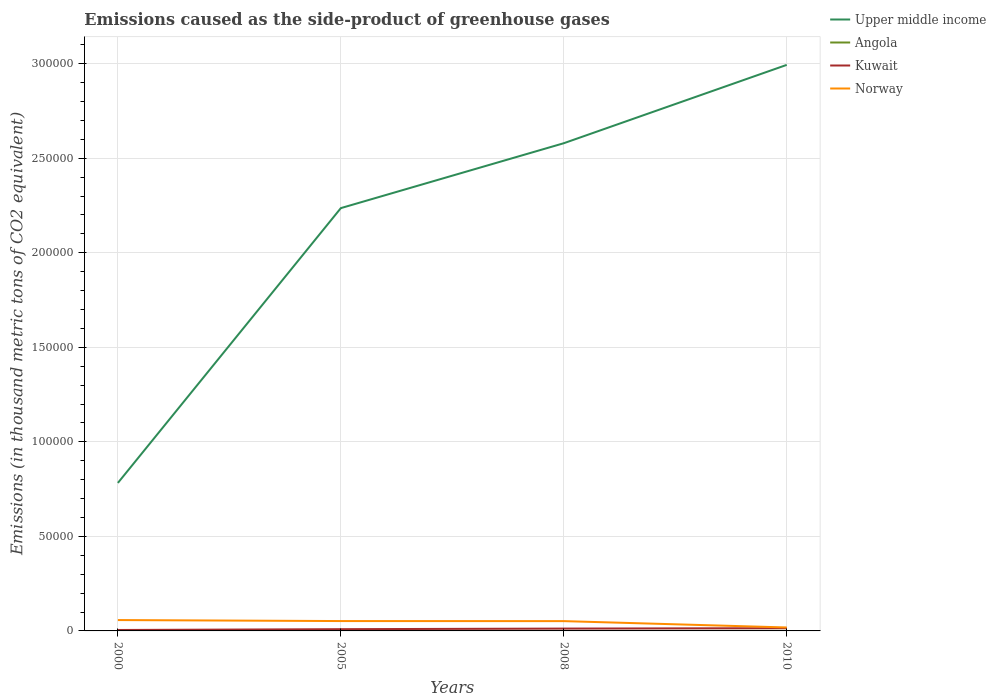How many different coloured lines are there?
Offer a terse response. 4. Does the line corresponding to Norway intersect with the line corresponding to Kuwait?
Ensure brevity in your answer.  No. Is the number of lines equal to the number of legend labels?
Your response must be concise. Yes. Across all years, what is the maximum emissions caused as the side-product of greenhouse gases in Upper middle income?
Your response must be concise. 7.83e+04. In which year was the emissions caused as the side-product of greenhouse gases in Angola maximum?
Ensure brevity in your answer.  2000. What is the total emissions caused as the side-product of greenhouse gases in Upper middle income in the graph?
Your response must be concise. -2.21e+05. What is the difference between the highest and the second highest emissions caused as the side-product of greenhouse gases in Kuwait?
Offer a terse response. 952.8. What is the difference between the highest and the lowest emissions caused as the side-product of greenhouse gases in Angola?
Provide a succinct answer. 2. How many lines are there?
Keep it short and to the point. 4. Where does the legend appear in the graph?
Provide a short and direct response. Top right. How many legend labels are there?
Your answer should be compact. 4. How are the legend labels stacked?
Give a very brief answer. Vertical. What is the title of the graph?
Give a very brief answer. Emissions caused as the side-product of greenhouse gases. Does "South Sudan" appear as one of the legend labels in the graph?
Your response must be concise. No. What is the label or title of the X-axis?
Keep it short and to the point. Years. What is the label or title of the Y-axis?
Ensure brevity in your answer.  Emissions (in thousand metric tons of CO2 equivalent). What is the Emissions (in thousand metric tons of CO2 equivalent) in Upper middle income in 2000?
Your answer should be very brief. 7.83e+04. What is the Emissions (in thousand metric tons of CO2 equivalent) of Angola in 2000?
Offer a very short reply. 0.7. What is the Emissions (in thousand metric tons of CO2 equivalent) in Kuwait in 2000?
Offer a terse response. 498.2. What is the Emissions (in thousand metric tons of CO2 equivalent) in Norway in 2000?
Your response must be concise. 5742.8. What is the Emissions (in thousand metric tons of CO2 equivalent) in Upper middle income in 2005?
Give a very brief answer. 2.24e+05. What is the Emissions (in thousand metric tons of CO2 equivalent) of Angola in 2005?
Provide a short and direct response. 19.3. What is the Emissions (in thousand metric tons of CO2 equivalent) in Kuwait in 2005?
Keep it short and to the point. 925.6. What is the Emissions (in thousand metric tons of CO2 equivalent) in Norway in 2005?
Ensure brevity in your answer.  5218.5. What is the Emissions (in thousand metric tons of CO2 equivalent) in Upper middle income in 2008?
Ensure brevity in your answer.  2.58e+05. What is the Emissions (in thousand metric tons of CO2 equivalent) in Angola in 2008?
Give a very brief answer. 26.5. What is the Emissions (in thousand metric tons of CO2 equivalent) of Kuwait in 2008?
Keep it short and to the point. 1235.4. What is the Emissions (in thousand metric tons of CO2 equivalent) in Norway in 2008?
Your response must be concise. 5179.9. What is the Emissions (in thousand metric tons of CO2 equivalent) in Upper middle income in 2010?
Your response must be concise. 2.99e+05. What is the Emissions (in thousand metric tons of CO2 equivalent) in Kuwait in 2010?
Give a very brief answer. 1451. What is the Emissions (in thousand metric tons of CO2 equivalent) of Norway in 2010?
Your response must be concise. 1823. Across all years, what is the maximum Emissions (in thousand metric tons of CO2 equivalent) in Upper middle income?
Keep it short and to the point. 2.99e+05. Across all years, what is the maximum Emissions (in thousand metric tons of CO2 equivalent) of Kuwait?
Your response must be concise. 1451. Across all years, what is the maximum Emissions (in thousand metric tons of CO2 equivalent) of Norway?
Keep it short and to the point. 5742.8. Across all years, what is the minimum Emissions (in thousand metric tons of CO2 equivalent) in Upper middle income?
Give a very brief answer. 7.83e+04. Across all years, what is the minimum Emissions (in thousand metric tons of CO2 equivalent) of Angola?
Offer a terse response. 0.7. Across all years, what is the minimum Emissions (in thousand metric tons of CO2 equivalent) of Kuwait?
Give a very brief answer. 498.2. Across all years, what is the minimum Emissions (in thousand metric tons of CO2 equivalent) of Norway?
Your answer should be compact. 1823. What is the total Emissions (in thousand metric tons of CO2 equivalent) of Upper middle income in the graph?
Your response must be concise. 8.59e+05. What is the total Emissions (in thousand metric tons of CO2 equivalent) in Angola in the graph?
Provide a short and direct response. 77.5. What is the total Emissions (in thousand metric tons of CO2 equivalent) of Kuwait in the graph?
Your answer should be compact. 4110.2. What is the total Emissions (in thousand metric tons of CO2 equivalent) of Norway in the graph?
Your answer should be very brief. 1.80e+04. What is the difference between the Emissions (in thousand metric tons of CO2 equivalent) of Upper middle income in 2000 and that in 2005?
Give a very brief answer. -1.45e+05. What is the difference between the Emissions (in thousand metric tons of CO2 equivalent) of Angola in 2000 and that in 2005?
Provide a short and direct response. -18.6. What is the difference between the Emissions (in thousand metric tons of CO2 equivalent) of Kuwait in 2000 and that in 2005?
Keep it short and to the point. -427.4. What is the difference between the Emissions (in thousand metric tons of CO2 equivalent) in Norway in 2000 and that in 2005?
Give a very brief answer. 524.3. What is the difference between the Emissions (in thousand metric tons of CO2 equivalent) of Upper middle income in 2000 and that in 2008?
Ensure brevity in your answer.  -1.80e+05. What is the difference between the Emissions (in thousand metric tons of CO2 equivalent) in Angola in 2000 and that in 2008?
Your answer should be compact. -25.8. What is the difference between the Emissions (in thousand metric tons of CO2 equivalent) of Kuwait in 2000 and that in 2008?
Provide a short and direct response. -737.2. What is the difference between the Emissions (in thousand metric tons of CO2 equivalent) in Norway in 2000 and that in 2008?
Ensure brevity in your answer.  562.9. What is the difference between the Emissions (in thousand metric tons of CO2 equivalent) in Upper middle income in 2000 and that in 2010?
Provide a succinct answer. -2.21e+05. What is the difference between the Emissions (in thousand metric tons of CO2 equivalent) in Angola in 2000 and that in 2010?
Provide a succinct answer. -30.3. What is the difference between the Emissions (in thousand metric tons of CO2 equivalent) of Kuwait in 2000 and that in 2010?
Provide a short and direct response. -952.8. What is the difference between the Emissions (in thousand metric tons of CO2 equivalent) in Norway in 2000 and that in 2010?
Provide a succinct answer. 3919.8. What is the difference between the Emissions (in thousand metric tons of CO2 equivalent) in Upper middle income in 2005 and that in 2008?
Keep it short and to the point. -3.43e+04. What is the difference between the Emissions (in thousand metric tons of CO2 equivalent) in Angola in 2005 and that in 2008?
Offer a terse response. -7.2. What is the difference between the Emissions (in thousand metric tons of CO2 equivalent) of Kuwait in 2005 and that in 2008?
Make the answer very short. -309.8. What is the difference between the Emissions (in thousand metric tons of CO2 equivalent) in Norway in 2005 and that in 2008?
Provide a succinct answer. 38.6. What is the difference between the Emissions (in thousand metric tons of CO2 equivalent) of Upper middle income in 2005 and that in 2010?
Provide a succinct answer. -7.58e+04. What is the difference between the Emissions (in thousand metric tons of CO2 equivalent) in Kuwait in 2005 and that in 2010?
Ensure brevity in your answer.  -525.4. What is the difference between the Emissions (in thousand metric tons of CO2 equivalent) in Norway in 2005 and that in 2010?
Provide a succinct answer. 3395.5. What is the difference between the Emissions (in thousand metric tons of CO2 equivalent) of Upper middle income in 2008 and that in 2010?
Give a very brief answer. -4.14e+04. What is the difference between the Emissions (in thousand metric tons of CO2 equivalent) in Angola in 2008 and that in 2010?
Give a very brief answer. -4.5. What is the difference between the Emissions (in thousand metric tons of CO2 equivalent) of Kuwait in 2008 and that in 2010?
Your answer should be compact. -215.6. What is the difference between the Emissions (in thousand metric tons of CO2 equivalent) in Norway in 2008 and that in 2010?
Your response must be concise. 3356.9. What is the difference between the Emissions (in thousand metric tons of CO2 equivalent) in Upper middle income in 2000 and the Emissions (in thousand metric tons of CO2 equivalent) in Angola in 2005?
Offer a very short reply. 7.83e+04. What is the difference between the Emissions (in thousand metric tons of CO2 equivalent) of Upper middle income in 2000 and the Emissions (in thousand metric tons of CO2 equivalent) of Kuwait in 2005?
Offer a terse response. 7.74e+04. What is the difference between the Emissions (in thousand metric tons of CO2 equivalent) of Upper middle income in 2000 and the Emissions (in thousand metric tons of CO2 equivalent) of Norway in 2005?
Offer a terse response. 7.31e+04. What is the difference between the Emissions (in thousand metric tons of CO2 equivalent) of Angola in 2000 and the Emissions (in thousand metric tons of CO2 equivalent) of Kuwait in 2005?
Your answer should be very brief. -924.9. What is the difference between the Emissions (in thousand metric tons of CO2 equivalent) in Angola in 2000 and the Emissions (in thousand metric tons of CO2 equivalent) in Norway in 2005?
Your answer should be very brief. -5217.8. What is the difference between the Emissions (in thousand metric tons of CO2 equivalent) of Kuwait in 2000 and the Emissions (in thousand metric tons of CO2 equivalent) of Norway in 2005?
Give a very brief answer. -4720.3. What is the difference between the Emissions (in thousand metric tons of CO2 equivalent) of Upper middle income in 2000 and the Emissions (in thousand metric tons of CO2 equivalent) of Angola in 2008?
Your response must be concise. 7.83e+04. What is the difference between the Emissions (in thousand metric tons of CO2 equivalent) in Upper middle income in 2000 and the Emissions (in thousand metric tons of CO2 equivalent) in Kuwait in 2008?
Your answer should be very brief. 7.70e+04. What is the difference between the Emissions (in thousand metric tons of CO2 equivalent) of Upper middle income in 2000 and the Emissions (in thousand metric tons of CO2 equivalent) of Norway in 2008?
Your answer should be compact. 7.31e+04. What is the difference between the Emissions (in thousand metric tons of CO2 equivalent) of Angola in 2000 and the Emissions (in thousand metric tons of CO2 equivalent) of Kuwait in 2008?
Provide a succinct answer. -1234.7. What is the difference between the Emissions (in thousand metric tons of CO2 equivalent) of Angola in 2000 and the Emissions (in thousand metric tons of CO2 equivalent) of Norway in 2008?
Keep it short and to the point. -5179.2. What is the difference between the Emissions (in thousand metric tons of CO2 equivalent) in Kuwait in 2000 and the Emissions (in thousand metric tons of CO2 equivalent) in Norway in 2008?
Provide a succinct answer. -4681.7. What is the difference between the Emissions (in thousand metric tons of CO2 equivalent) in Upper middle income in 2000 and the Emissions (in thousand metric tons of CO2 equivalent) in Angola in 2010?
Offer a very short reply. 7.83e+04. What is the difference between the Emissions (in thousand metric tons of CO2 equivalent) in Upper middle income in 2000 and the Emissions (in thousand metric tons of CO2 equivalent) in Kuwait in 2010?
Ensure brevity in your answer.  7.68e+04. What is the difference between the Emissions (in thousand metric tons of CO2 equivalent) in Upper middle income in 2000 and the Emissions (in thousand metric tons of CO2 equivalent) in Norway in 2010?
Make the answer very short. 7.65e+04. What is the difference between the Emissions (in thousand metric tons of CO2 equivalent) of Angola in 2000 and the Emissions (in thousand metric tons of CO2 equivalent) of Kuwait in 2010?
Make the answer very short. -1450.3. What is the difference between the Emissions (in thousand metric tons of CO2 equivalent) in Angola in 2000 and the Emissions (in thousand metric tons of CO2 equivalent) in Norway in 2010?
Make the answer very short. -1822.3. What is the difference between the Emissions (in thousand metric tons of CO2 equivalent) of Kuwait in 2000 and the Emissions (in thousand metric tons of CO2 equivalent) of Norway in 2010?
Ensure brevity in your answer.  -1324.8. What is the difference between the Emissions (in thousand metric tons of CO2 equivalent) of Upper middle income in 2005 and the Emissions (in thousand metric tons of CO2 equivalent) of Angola in 2008?
Your answer should be very brief. 2.24e+05. What is the difference between the Emissions (in thousand metric tons of CO2 equivalent) in Upper middle income in 2005 and the Emissions (in thousand metric tons of CO2 equivalent) in Kuwait in 2008?
Offer a very short reply. 2.22e+05. What is the difference between the Emissions (in thousand metric tons of CO2 equivalent) of Upper middle income in 2005 and the Emissions (in thousand metric tons of CO2 equivalent) of Norway in 2008?
Your answer should be compact. 2.18e+05. What is the difference between the Emissions (in thousand metric tons of CO2 equivalent) in Angola in 2005 and the Emissions (in thousand metric tons of CO2 equivalent) in Kuwait in 2008?
Make the answer very short. -1216.1. What is the difference between the Emissions (in thousand metric tons of CO2 equivalent) in Angola in 2005 and the Emissions (in thousand metric tons of CO2 equivalent) in Norway in 2008?
Provide a succinct answer. -5160.6. What is the difference between the Emissions (in thousand metric tons of CO2 equivalent) in Kuwait in 2005 and the Emissions (in thousand metric tons of CO2 equivalent) in Norway in 2008?
Your response must be concise. -4254.3. What is the difference between the Emissions (in thousand metric tons of CO2 equivalent) in Upper middle income in 2005 and the Emissions (in thousand metric tons of CO2 equivalent) in Angola in 2010?
Ensure brevity in your answer.  2.24e+05. What is the difference between the Emissions (in thousand metric tons of CO2 equivalent) in Upper middle income in 2005 and the Emissions (in thousand metric tons of CO2 equivalent) in Kuwait in 2010?
Give a very brief answer. 2.22e+05. What is the difference between the Emissions (in thousand metric tons of CO2 equivalent) in Upper middle income in 2005 and the Emissions (in thousand metric tons of CO2 equivalent) in Norway in 2010?
Offer a terse response. 2.22e+05. What is the difference between the Emissions (in thousand metric tons of CO2 equivalent) in Angola in 2005 and the Emissions (in thousand metric tons of CO2 equivalent) in Kuwait in 2010?
Give a very brief answer. -1431.7. What is the difference between the Emissions (in thousand metric tons of CO2 equivalent) of Angola in 2005 and the Emissions (in thousand metric tons of CO2 equivalent) of Norway in 2010?
Your response must be concise. -1803.7. What is the difference between the Emissions (in thousand metric tons of CO2 equivalent) of Kuwait in 2005 and the Emissions (in thousand metric tons of CO2 equivalent) of Norway in 2010?
Your answer should be very brief. -897.4. What is the difference between the Emissions (in thousand metric tons of CO2 equivalent) of Upper middle income in 2008 and the Emissions (in thousand metric tons of CO2 equivalent) of Angola in 2010?
Your response must be concise. 2.58e+05. What is the difference between the Emissions (in thousand metric tons of CO2 equivalent) of Upper middle income in 2008 and the Emissions (in thousand metric tons of CO2 equivalent) of Kuwait in 2010?
Offer a very short reply. 2.57e+05. What is the difference between the Emissions (in thousand metric tons of CO2 equivalent) in Upper middle income in 2008 and the Emissions (in thousand metric tons of CO2 equivalent) in Norway in 2010?
Make the answer very short. 2.56e+05. What is the difference between the Emissions (in thousand metric tons of CO2 equivalent) of Angola in 2008 and the Emissions (in thousand metric tons of CO2 equivalent) of Kuwait in 2010?
Provide a succinct answer. -1424.5. What is the difference between the Emissions (in thousand metric tons of CO2 equivalent) of Angola in 2008 and the Emissions (in thousand metric tons of CO2 equivalent) of Norway in 2010?
Offer a very short reply. -1796.5. What is the difference between the Emissions (in thousand metric tons of CO2 equivalent) of Kuwait in 2008 and the Emissions (in thousand metric tons of CO2 equivalent) of Norway in 2010?
Offer a very short reply. -587.6. What is the average Emissions (in thousand metric tons of CO2 equivalent) of Upper middle income per year?
Your answer should be compact. 2.15e+05. What is the average Emissions (in thousand metric tons of CO2 equivalent) of Angola per year?
Ensure brevity in your answer.  19.38. What is the average Emissions (in thousand metric tons of CO2 equivalent) in Kuwait per year?
Your response must be concise. 1027.55. What is the average Emissions (in thousand metric tons of CO2 equivalent) of Norway per year?
Ensure brevity in your answer.  4491.05. In the year 2000, what is the difference between the Emissions (in thousand metric tons of CO2 equivalent) in Upper middle income and Emissions (in thousand metric tons of CO2 equivalent) in Angola?
Ensure brevity in your answer.  7.83e+04. In the year 2000, what is the difference between the Emissions (in thousand metric tons of CO2 equivalent) of Upper middle income and Emissions (in thousand metric tons of CO2 equivalent) of Kuwait?
Your answer should be compact. 7.78e+04. In the year 2000, what is the difference between the Emissions (in thousand metric tons of CO2 equivalent) of Upper middle income and Emissions (in thousand metric tons of CO2 equivalent) of Norway?
Provide a succinct answer. 7.25e+04. In the year 2000, what is the difference between the Emissions (in thousand metric tons of CO2 equivalent) in Angola and Emissions (in thousand metric tons of CO2 equivalent) in Kuwait?
Your response must be concise. -497.5. In the year 2000, what is the difference between the Emissions (in thousand metric tons of CO2 equivalent) of Angola and Emissions (in thousand metric tons of CO2 equivalent) of Norway?
Provide a succinct answer. -5742.1. In the year 2000, what is the difference between the Emissions (in thousand metric tons of CO2 equivalent) of Kuwait and Emissions (in thousand metric tons of CO2 equivalent) of Norway?
Your answer should be very brief. -5244.6. In the year 2005, what is the difference between the Emissions (in thousand metric tons of CO2 equivalent) in Upper middle income and Emissions (in thousand metric tons of CO2 equivalent) in Angola?
Give a very brief answer. 2.24e+05. In the year 2005, what is the difference between the Emissions (in thousand metric tons of CO2 equivalent) in Upper middle income and Emissions (in thousand metric tons of CO2 equivalent) in Kuwait?
Ensure brevity in your answer.  2.23e+05. In the year 2005, what is the difference between the Emissions (in thousand metric tons of CO2 equivalent) of Upper middle income and Emissions (in thousand metric tons of CO2 equivalent) of Norway?
Ensure brevity in your answer.  2.18e+05. In the year 2005, what is the difference between the Emissions (in thousand metric tons of CO2 equivalent) in Angola and Emissions (in thousand metric tons of CO2 equivalent) in Kuwait?
Provide a succinct answer. -906.3. In the year 2005, what is the difference between the Emissions (in thousand metric tons of CO2 equivalent) of Angola and Emissions (in thousand metric tons of CO2 equivalent) of Norway?
Make the answer very short. -5199.2. In the year 2005, what is the difference between the Emissions (in thousand metric tons of CO2 equivalent) in Kuwait and Emissions (in thousand metric tons of CO2 equivalent) in Norway?
Give a very brief answer. -4292.9. In the year 2008, what is the difference between the Emissions (in thousand metric tons of CO2 equivalent) in Upper middle income and Emissions (in thousand metric tons of CO2 equivalent) in Angola?
Your answer should be compact. 2.58e+05. In the year 2008, what is the difference between the Emissions (in thousand metric tons of CO2 equivalent) in Upper middle income and Emissions (in thousand metric tons of CO2 equivalent) in Kuwait?
Offer a very short reply. 2.57e+05. In the year 2008, what is the difference between the Emissions (in thousand metric tons of CO2 equivalent) of Upper middle income and Emissions (in thousand metric tons of CO2 equivalent) of Norway?
Provide a short and direct response. 2.53e+05. In the year 2008, what is the difference between the Emissions (in thousand metric tons of CO2 equivalent) in Angola and Emissions (in thousand metric tons of CO2 equivalent) in Kuwait?
Offer a very short reply. -1208.9. In the year 2008, what is the difference between the Emissions (in thousand metric tons of CO2 equivalent) of Angola and Emissions (in thousand metric tons of CO2 equivalent) of Norway?
Provide a succinct answer. -5153.4. In the year 2008, what is the difference between the Emissions (in thousand metric tons of CO2 equivalent) of Kuwait and Emissions (in thousand metric tons of CO2 equivalent) of Norway?
Offer a terse response. -3944.5. In the year 2010, what is the difference between the Emissions (in thousand metric tons of CO2 equivalent) in Upper middle income and Emissions (in thousand metric tons of CO2 equivalent) in Angola?
Offer a very short reply. 2.99e+05. In the year 2010, what is the difference between the Emissions (in thousand metric tons of CO2 equivalent) of Upper middle income and Emissions (in thousand metric tons of CO2 equivalent) of Kuwait?
Provide a succinct answer. 2.98e+05. In the year 2010, what is the difference between the Emissions (in thousand metric tons of CO2 equivalent) in Upper middle income and Emissions (in thousand metric tons of CO2 equivalent) in Norway?
Keep it short and to the point. 2.98e+05. In the year 2010, what is the difference between the Emissions (in thousand metric tons of CO2 equivalent) of Angola and Emissions (in thousand metric tons of CO2 equivalent) of Kuwait?
Make the answer very short. -1420. In the year 2010, what is the difference between the Emissions (in thousand metric tons of CO2 equivalent) in Angola and Emissions (in thousand metric tons of CO2 equivalent) in Norway?
Offer a terse response. -1792. In the year 2010, what is the difference between the Emissions (in thousand metric tons of CO2 equivalent) in Kuwait and Emissions (in thousand metric tons of CO2 equivalent) in Norway?
Make the answer very short. -372. What is the ratio of the Emissions (in thousand metric tons of CO2 equivalent) in Angola in 2000 to that in 2005?
Make the answer very short. 0.04. What is the ratio of the Emissions (in thousand metric tons of CO2 equivalent) in Kuwait in 2000 to that in 2005?
Your response must be concise. 0.54. What is the ratio of the Emissions (in thousand metric tons of CO2 equivalent) in Norway in 2000 to that in 2005?
Provide a succinct answer. 1.1. What is the ratio of the Emissions (in thousand metric tons of CO2 equivalent) in Upper middle income in 2000 to that in 2008?
Give a very brief answer. 0.3. What is the ratio of the Emissions (in thousand metric tons of CO2 equivalent) of Angola in 2000 to that in 2008?
Ensure brevity in your answer.  0.03. What is the ratio of the Emissions (in thousand metric tons of CO2 equivalent) of Kuwait in 2000 to that in 2008?
Make the answer very short. 0.4. What is the ratio of the Emissions (in thousand metric tons of CO2 equivalent) in Norway in 2000 to that in 2008?
Make the answer very short. 1.11. What is the ratio of the Emissions (in thousand metric tons of CO2 equivalent) of Upper middle income in 2000 to that in 2010?
Give a very brief answer. 0.26. What is the ratio of the Emissions (in thousand metric tons of CO2 equivalent) in Angola in 2000 to that in 2010?
Ensure brevity in your answer.  0.02. What is the ratio of the Emissions (in thousand metric tons of CO2 equivalent) in Kuwait in 2000 to that in 2010?
Give a very brief answer. 0.34. What is the ratio of the Emissions (in thousand metric tons of CO2 equivalent) of Norway in 2000 to that in 2010?
Ensure brevity in your answer.  3.15. What is the ratio of the Emissions (in thousand metric tons of CO2 equivalent) of Upper middle income in 2005 to that in 2008?
Your response must be concise. 0.87. What is the ratio of the Emissions (in thousand metric tons of CO2 equivalent) of Angola in 2005 to that in 2008?
Provide a short and direct response. 0.73. What is the ratio of the Emissions (in thousand metric tons of CO2 equivalent) of Kuwait in 2005 to that in 2008?
Provide a short and direct response. 0.75. What is the ratio of the Emissions (in thousand metric tons of CO2 equivalent) in Norway in 2005 to that in 2008?
Keep it short and to the point. 1.01. What is the ratio of the Emissions (in thousand metric tons of CO2 equivalent) in Upper middle income in 2005 to that in 2010?
Offer a terse response. 0.75. What is the ratio of the Emissions (in thousand metric tons of CO2 equivalent) of Angola in 2005 to that in 2010?
Make the answer very short. 0.62. What is the ratio of the Emissions (in thousand metric tons of CO2 equivalent) of Kuwait in 2005 to that in 2010?
Provide a short and direct response. 0.64. What is the ratio of the Emissions (in thousand metric tons of CO2 equivalent) of Norway in 2005 to that in 2010?
Make the answer very short. 2.86. What is the ratio of the Emissions (in thousand metric tons of CO2 equivalent) of Upper middle income in 2008 to that in 2010?
Provide a succinct answer. 0.86. What is the ratio of the Emissions (in thousand metric tons of CO2 equivalent) of Angola in 2008 to that in 2010?
Make the answer very short. 0.85. What is the ratio of the Emissions (in thousand metric tons of CO2 equivalent) in Kuwait in 2008 to that in 2010?
Provide a succinct answer. 0.85. What is the ratio of the Emissions (in thousand metric tons of CO2 equivalent) of Norway in 2008 to that in 2010?
Keep it short and to the point. 2.84. What is the difference between the highest and the second highest Emissions (in thousand metric tons of CO2 equivalent) of Upper middle income?
Offer a very short reply. 4.14e+04. What is the difference between the highest and the second highest Emissions (in thousand metric tons of CO2 equivalent) in Kuwait?
Offer a very short reply. 215.6. What is the difference between the highest and the second highest Emissions (in thousand metric tons of CO2 equivalent) in Norway?
Offer a terse response. 524.3. What is the difference between the highest and the lowest Emissions (in thousand metric tons of CO2 equivalent) in Upper middle income?
Provide a short and direct response. 2.21e+05. What is the difference between the highest and the lowest Emissions (in thousand metric tons of CO2 equivalent) in Angola?
Make the answer very short. 30.3. What is the difference between the highest and the lowest Emissions (in thousand metric tons of CO2 equivalent) of Kuwait?
Give a very brief answer. 952.8. What is the difference between the highest and the lowest Emissions (in thousand metric tons of CO2 equivalent) of Norway?
Keep it short and to the point. 3919.8. 